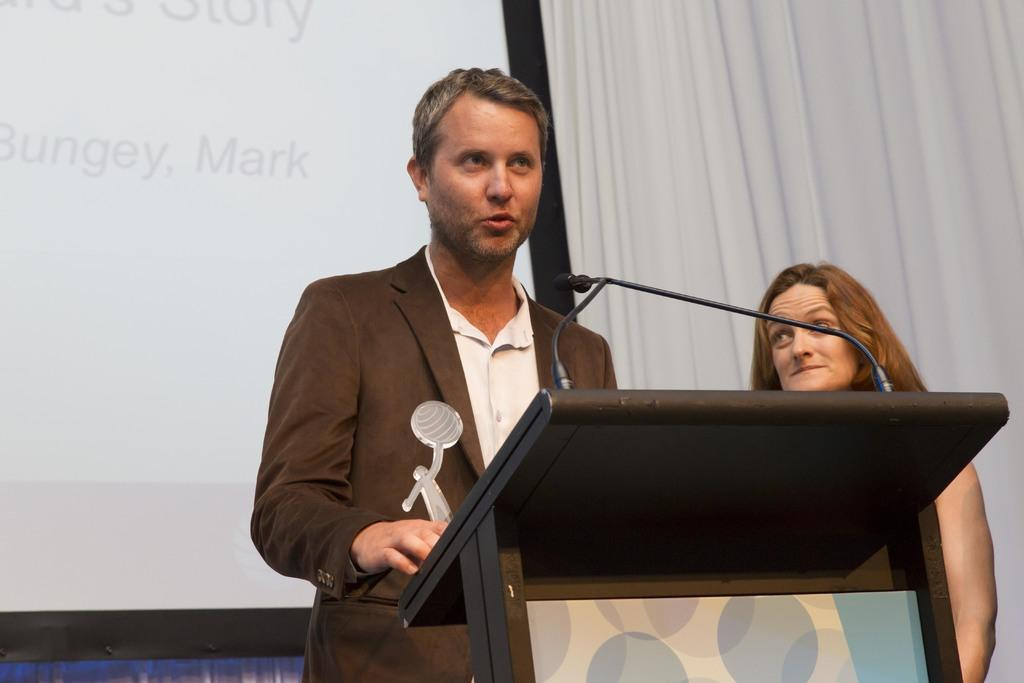Who are the people in the image? There is a guy and a lady in the image. What are the guy and the lady doing in the image? The guy and the lady are standing in front of a desk. What can be seen on the desk in the image? There is a mic on the desk. What is located behind the desk in the image? There is a projector screen behind the desk. Can you hear the bee buzzing in the image? There is no bee present in the image, so it cannot be heard buzzing. Why is the room so quiet in the image? The image does not provide any information about the noise level in the room, so we cannot determine if it is quiet or not. 